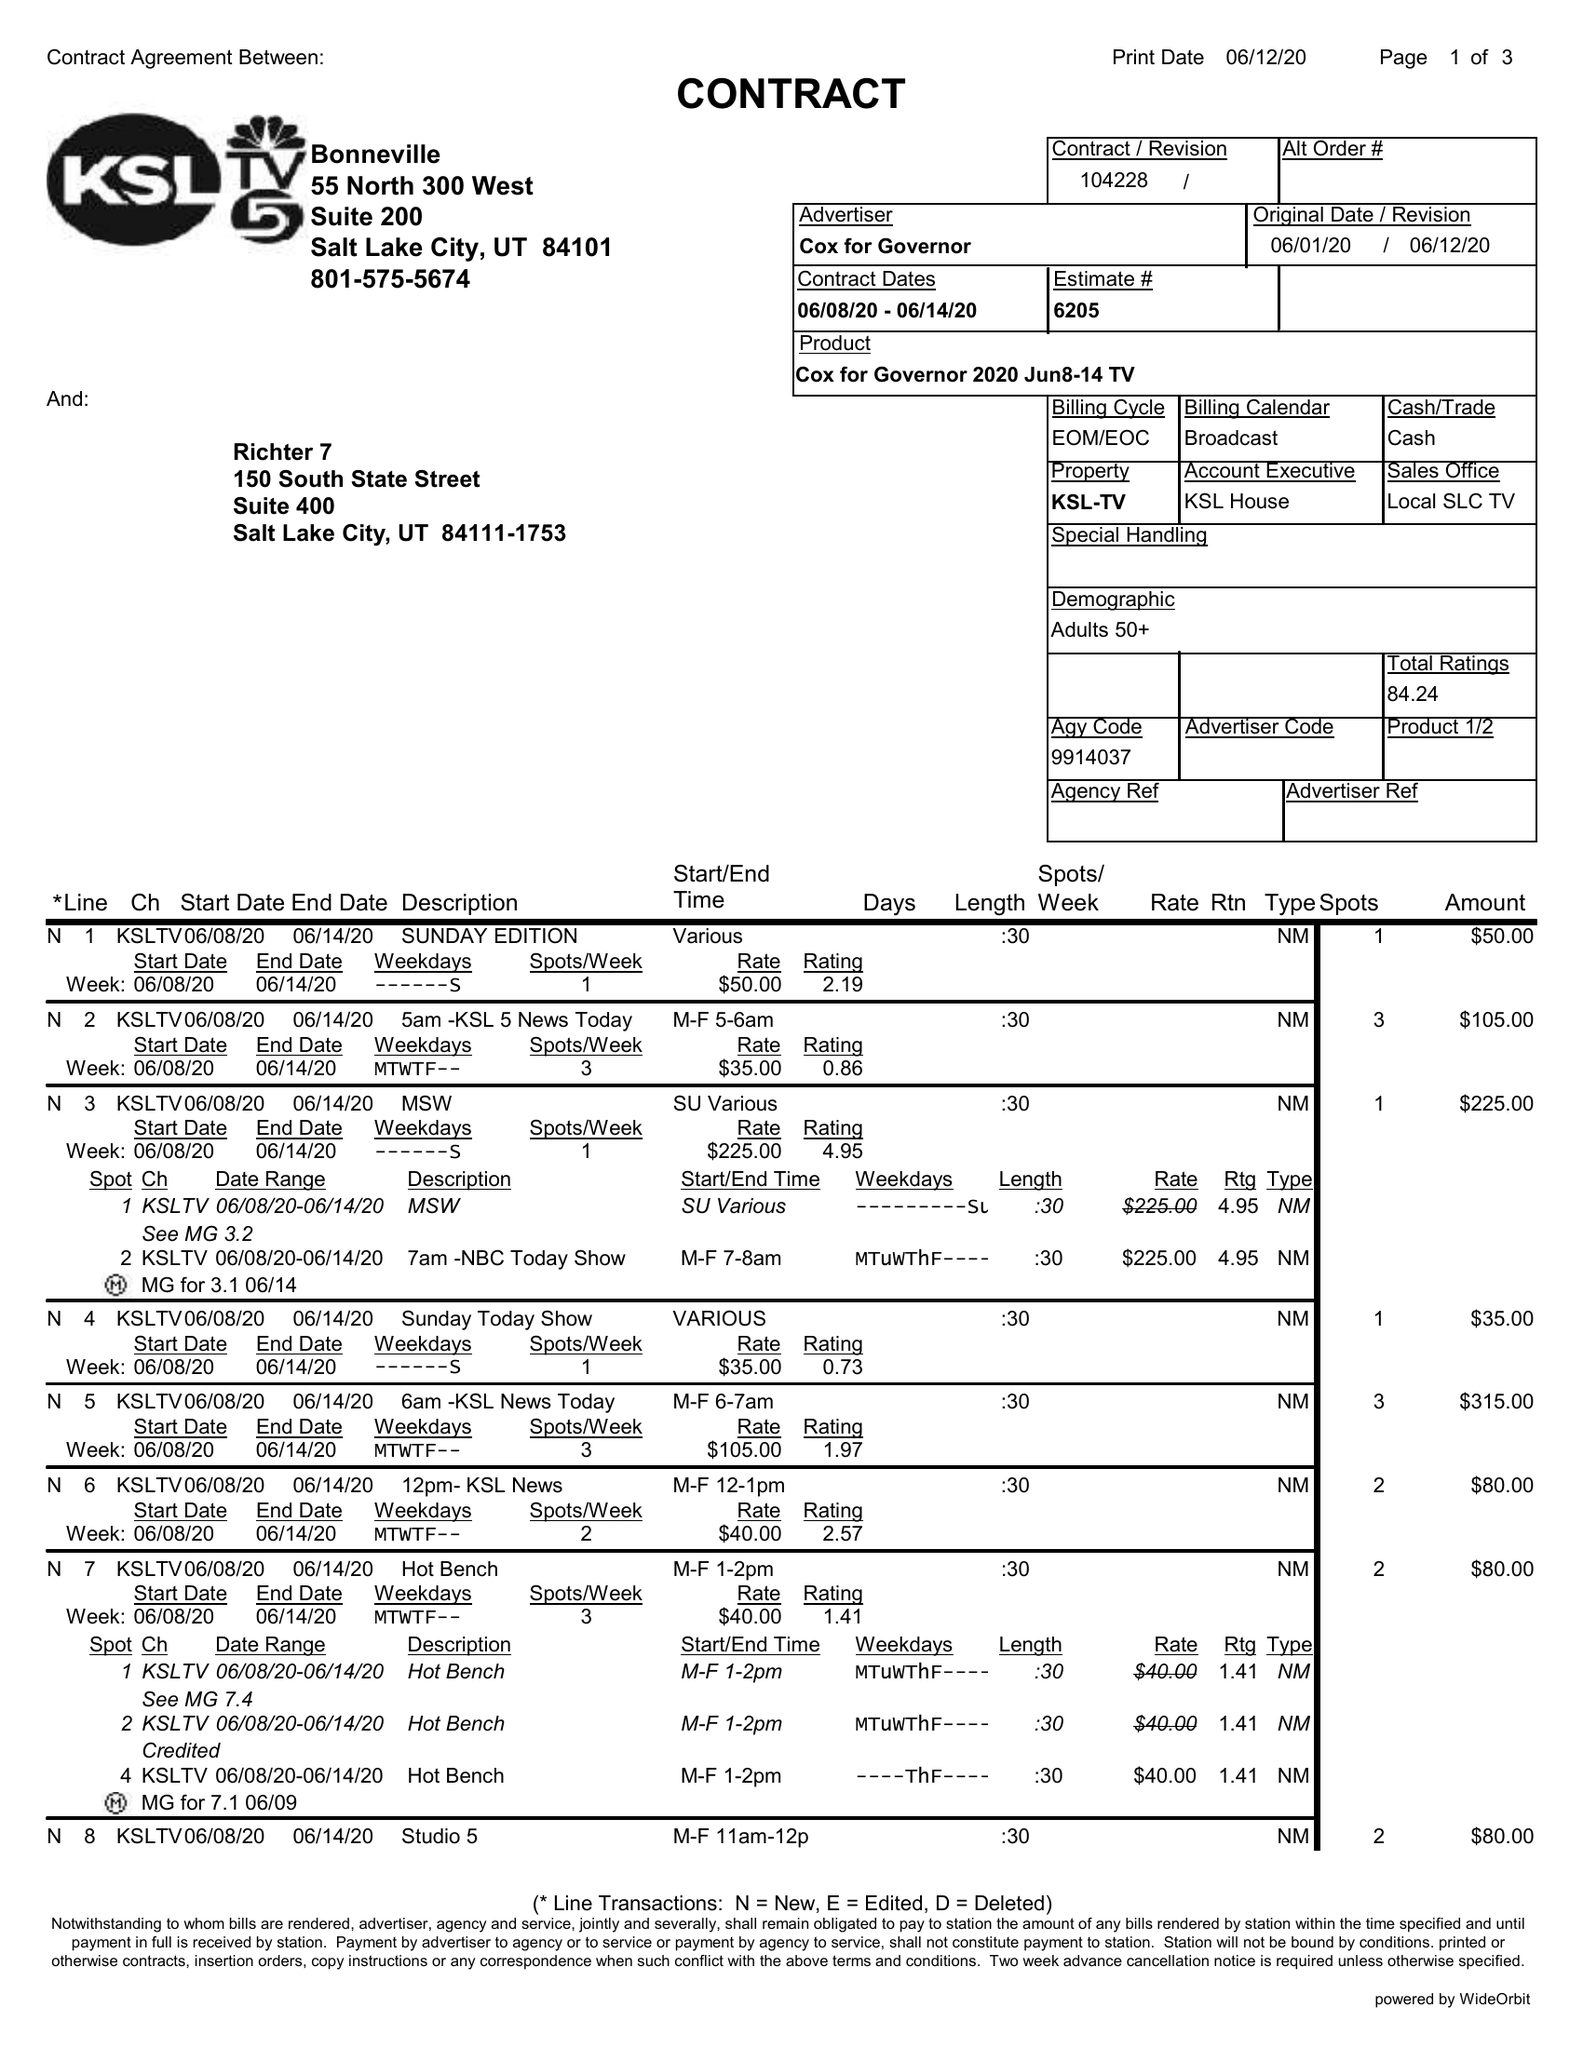What is the value for the flight_from?
Answer the question using a single word or phrase. 06/08/20 